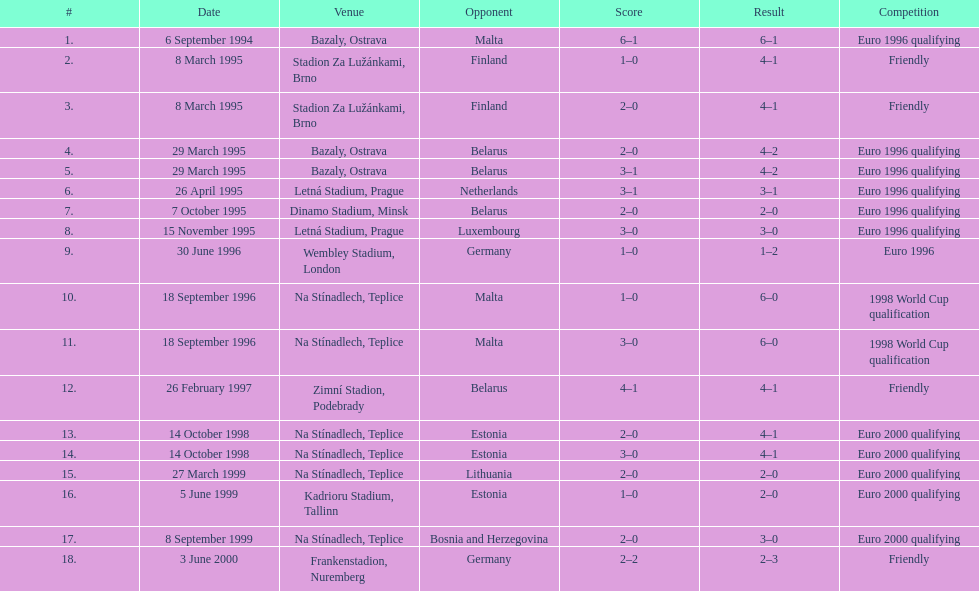Identify the participants involved in the friendly contest. Finland, Belarus, Germany. 